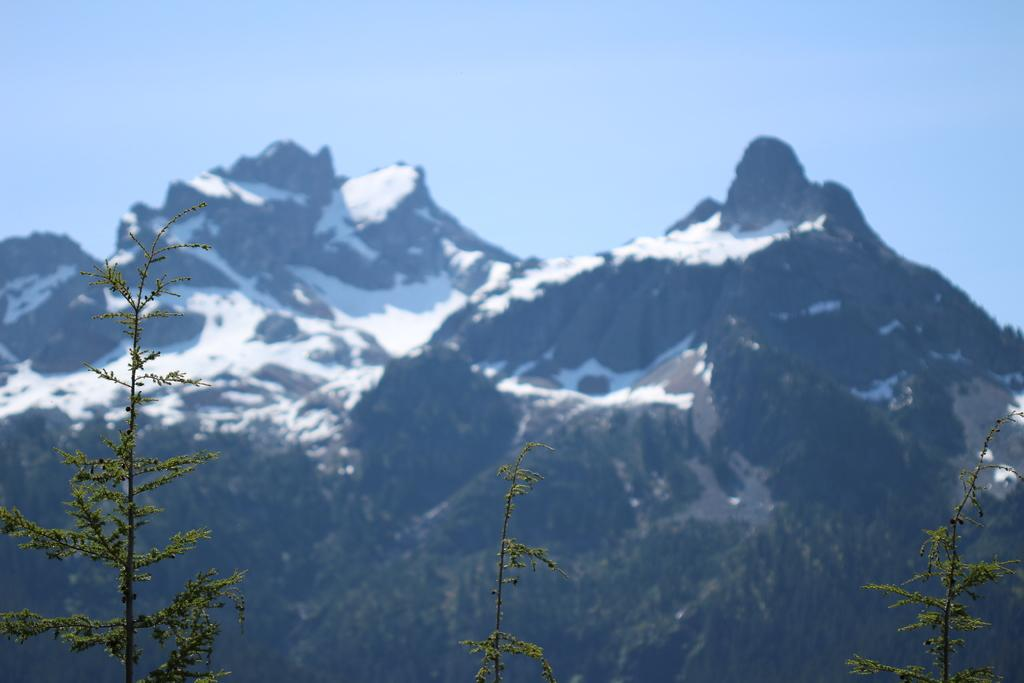What type of natural formation can be seen in the image? There are mountains with snow in the image. What other natural elements are present in the image? There are trees in the image. What color is the sky in the image? The sky is blue in the image. Can you see a dog holding a bone in the image? There is no dog or bone present in the image. Is there a person visible in the image? The image does not show any people; it primarily features mountains, trees, and a blue sky. 